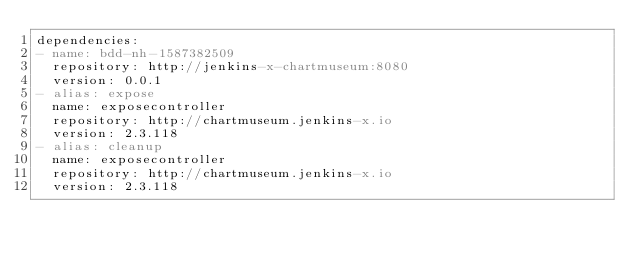<code> <loc_0><loc_0><loc_500><loc_500><_YAML_>dependencies:
- name: bdd-nh-1587382509
  repository: http://jenkins-x-chartmuseum:8080
  version: 0.0.1
- alias: expose
  name: exposecontroller
  repository: http://chartmuseum.jenkins-x.io
  version: 2.3.118
- alias: cleanup
  name: exposecontroller
  repository: http://chartmuseum.jenkins-x.io
  version: 2.3.118
</code> 